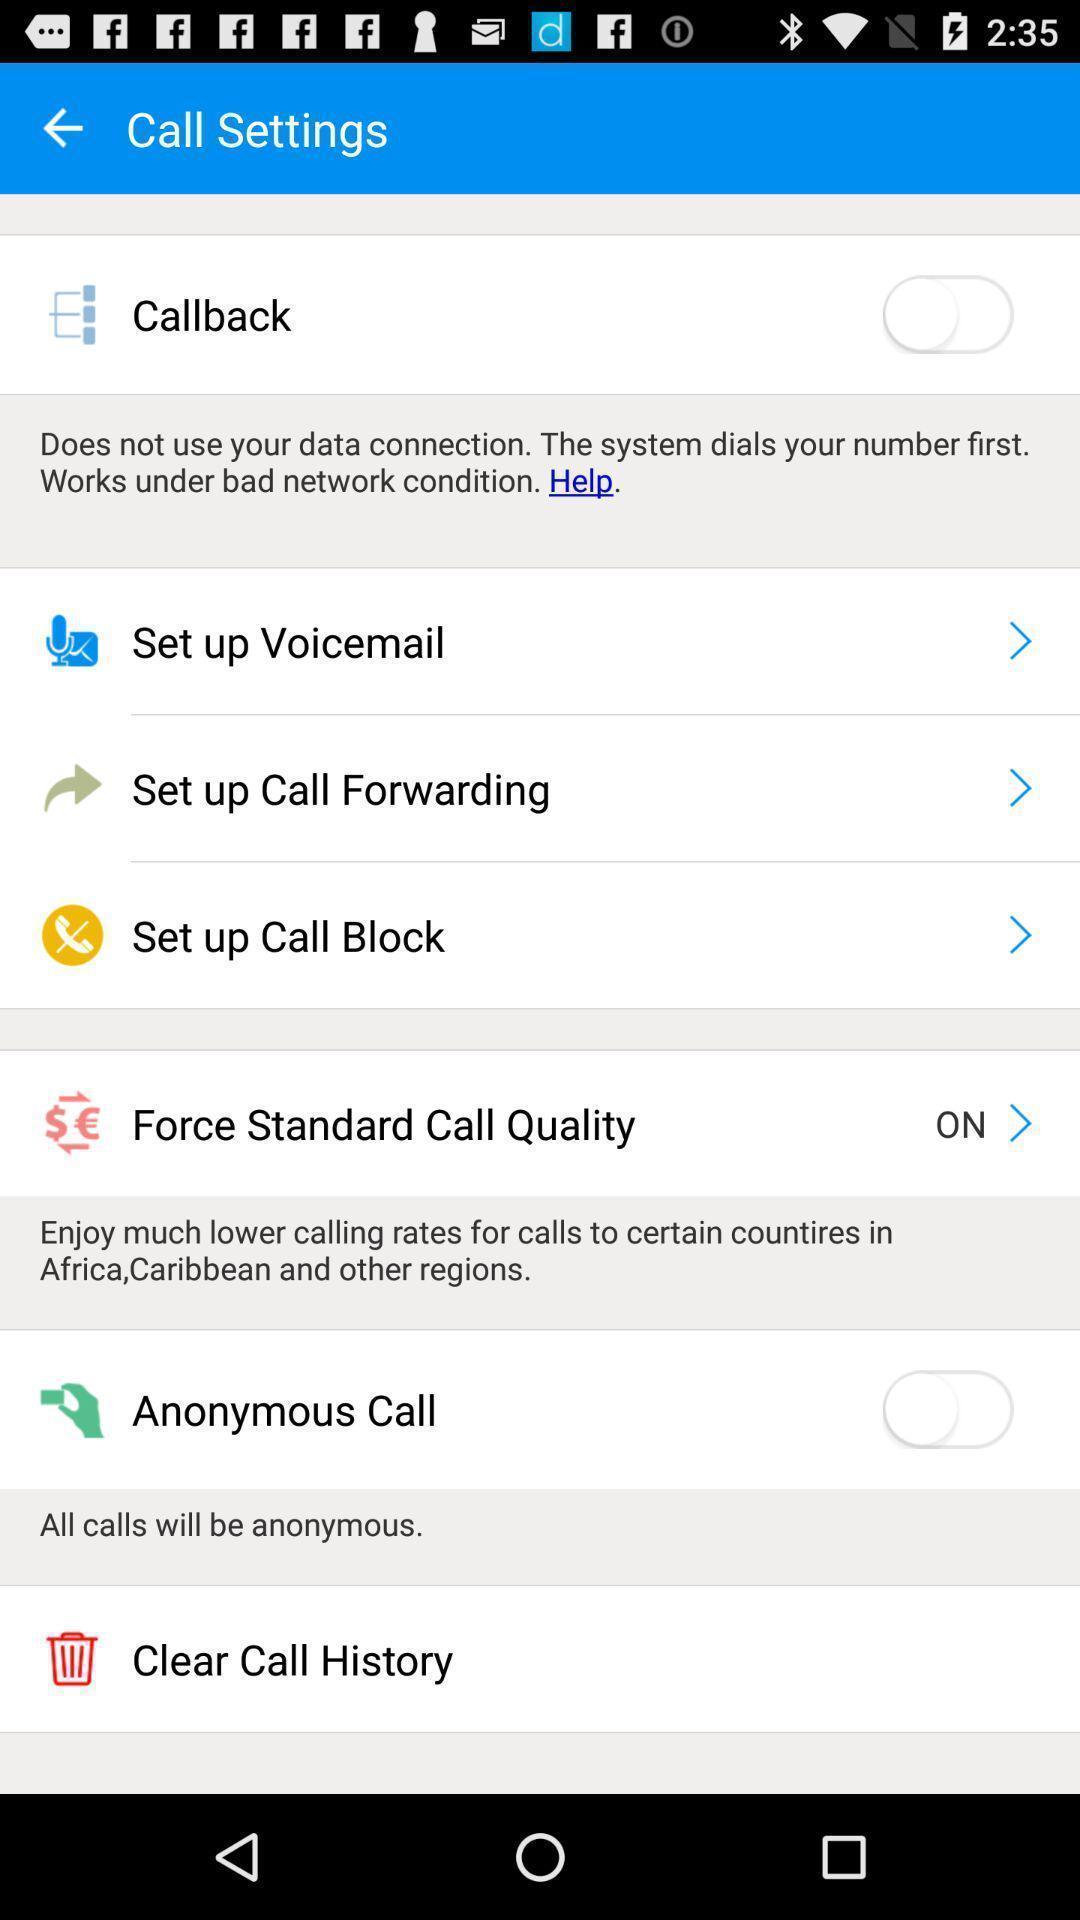Describe the visual elements of this screenshot. Screen displaying multiple setting options. 